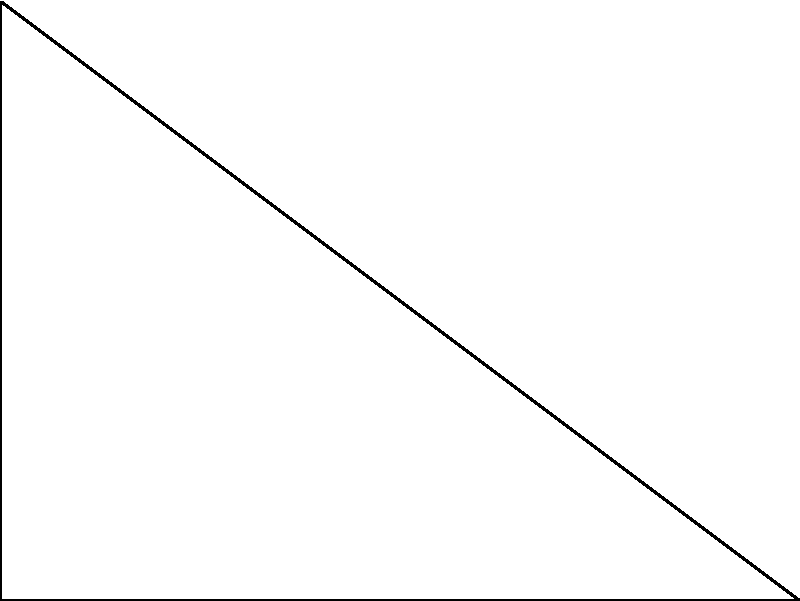In the right-angled triangle ABC shown above, the length of side AC is 3 units and the length of side AB is 4 units. What is the length of side BC? Let's solve this step-by-step using the Pythagorean theorem:

1) The Pythagorean theorem states that in a right-angled triangle, the square of the length of the hypotenuse (the side opposite the right angle) is equal to the sum of squares of the other two sides.

2) In this case, BC is the hypotenuse, and we need to find its length. Let's call this length $x$.

3) We can write the Pythagorean theorem as:
   $AC^2 + AB^2 = BC^2$

4) We know that $AC = 3$ and $AB = 4$. Let's substitute these values:
   $3^2 + 4^2 = x^2$

5) Simplify:
   $9 + 16 = x^2$
   $25 = x^2$

6) To find $x$, we need to take the square root of both sides:
   $\sqrt{25} = x$

7) Simplify:
   $5 = x$

Therefore, the length of side BC is 5 units.
Answer: 5 units 